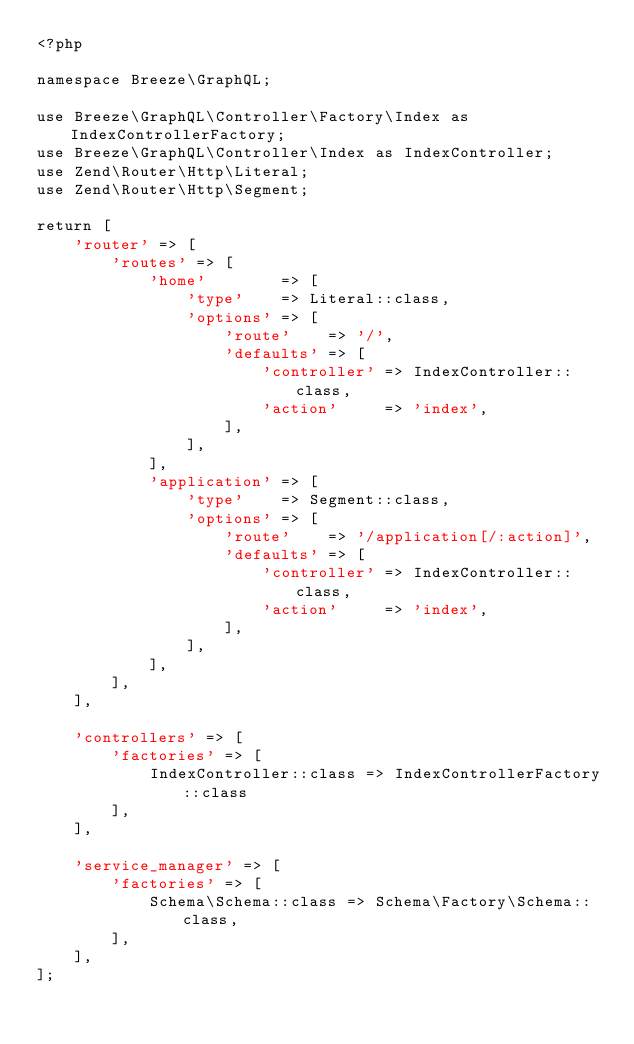Convert code to text. <code><loc_0><loc_0><loc_500><loc_500><_PHP_><?php

namespace Breeze\GraphQL;

use Breeze\GraphQL\Controller\Factory\Index as IndexControllerFactory;
use Breeze\GraphQL\Controller\Index as IndexController;
use Zend\Router\Http\Literal;
use Zend\Router\Http\Segment;

return [
    'router' => [
        'routes' => [
            'home'        => [
                'type'    => Literal::class,
                'options' => [
                    'route'    => '/',
                    'defaults' => [
                        'controller' => IndexController::class,
                        'action'     => 'index',
                    ],
                ],
            ],
            'application' => [
                'type'    => Segment::class,
                'options' => [
                    'route'    => '/application[/:action]',
                    'defaults' => [
                        'controller' => IndexController::class,
                        'action'     => 'index',
                    ],
                ],
            ],
        ],
    ],

    'controllers' => [
        'factories' => [
            IndexController::class => IndexControllerFactory::class
        ],
    ],

    'service_manager' => [
        'factories' => [
            Schema\Schema::class => Schema\Factory\Schema::class,
        ],
    ],
];
</code> 